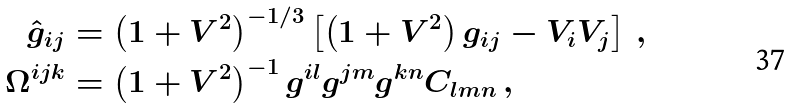Convert formula to latex. <formula><loc_0><loc_0><loc_500><loc_500>\hat { g } _ { i j } & = \left ( 1 + V ^ { 2 } \right ) ^ { - 1 / 3 } \left [ \left ( 1 + V ^ { 2 } \right ) g _ { i j } - V _ { i } V _ { j } \right ] \, , \\ \Omega ^ { i j k } & = \left ( 1 + V ^ { 2 } \right ) ^ { - 1 } g ^ { i l } g ^ { j m } g ^ { k n } C _ { l m n } \, ,</formula> 